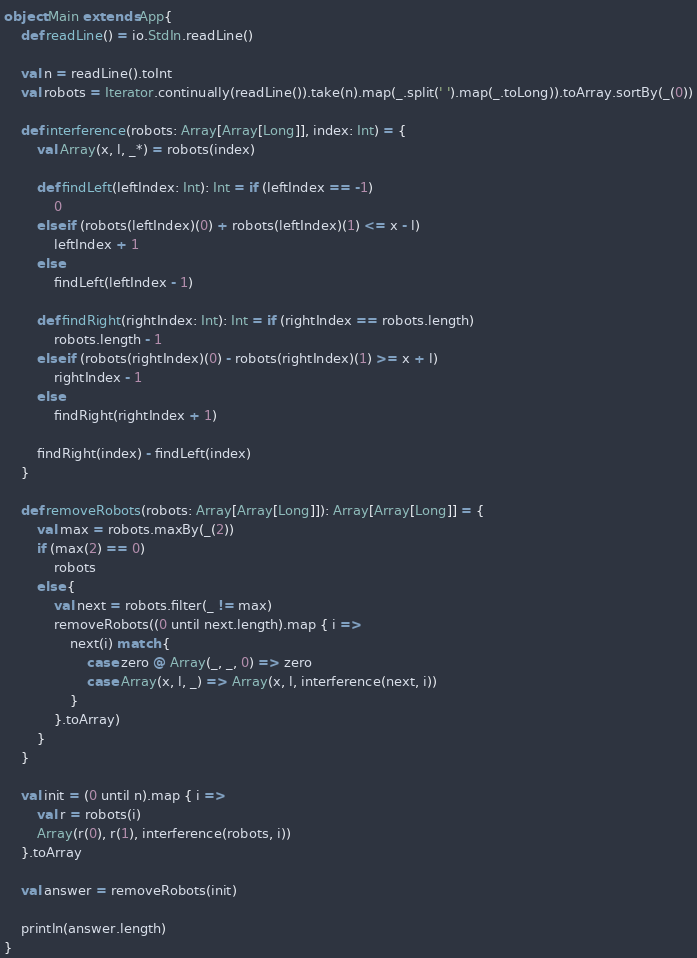<code> <loc_0><loc_0><loc_500><loc_500><_Scala_>object Main extends App{
    def readLine() = io.StdIn.readLine()
    
    val n = readLine().toInt
    val robots = Iterator.continually(readLine()).take(n).map(_.split(' ').map(_.toLong)).toArray.sortBy(_(0))
    
    def interference(robots: Array[Array[Long]], index: Int) = {
        val Array(x, l, _*) = robots(index)
        
        def findLeft(leftIndex: Int): Int = if (leftIndex == -1)
            0
        else if (robots(leftIndex)(0) + robots(leftIndex)(1) <= x - l)
            leftIndex + 1
        else
            findLeft(leftIndex - 1)
        
        def findRight(rightIndex: Int): Int = if (rightIndex == robots.length)
            robots.length - 1
        else if (robots(rightIndex)(0) - robots(rightIndex)(1) >= x + l)
            rightIndex - 1
        else
            findRight(rightIndex + 1)
        
        findRight(index) - findLeft(index)
    }
    
    def removeRobots(robots: Array[Array[Long]]): Array[Array[Long]] = {
        val max = robots.maxBy(_(2))
        if (max(2) == 0)
            robots
        else {
            val next = robots.filter(_ != max)
            removeRobots((0 until next.length).map { i =>
                next(i) match {
                    case zero @ Array(_, _, 0) => zero
                    case Array(x, l, _) => Array(x, l, interference(next, i))
                }
            }.toArray)
        }
    }
    
    val init = (0 until n).map { i =>
        val r = robots(i)
        Array(r(0), r(1), interference(robots, i))
    }.toArray
    
    val answer = removeRobots(init)
    
    println(answer.length)
}
</code> 